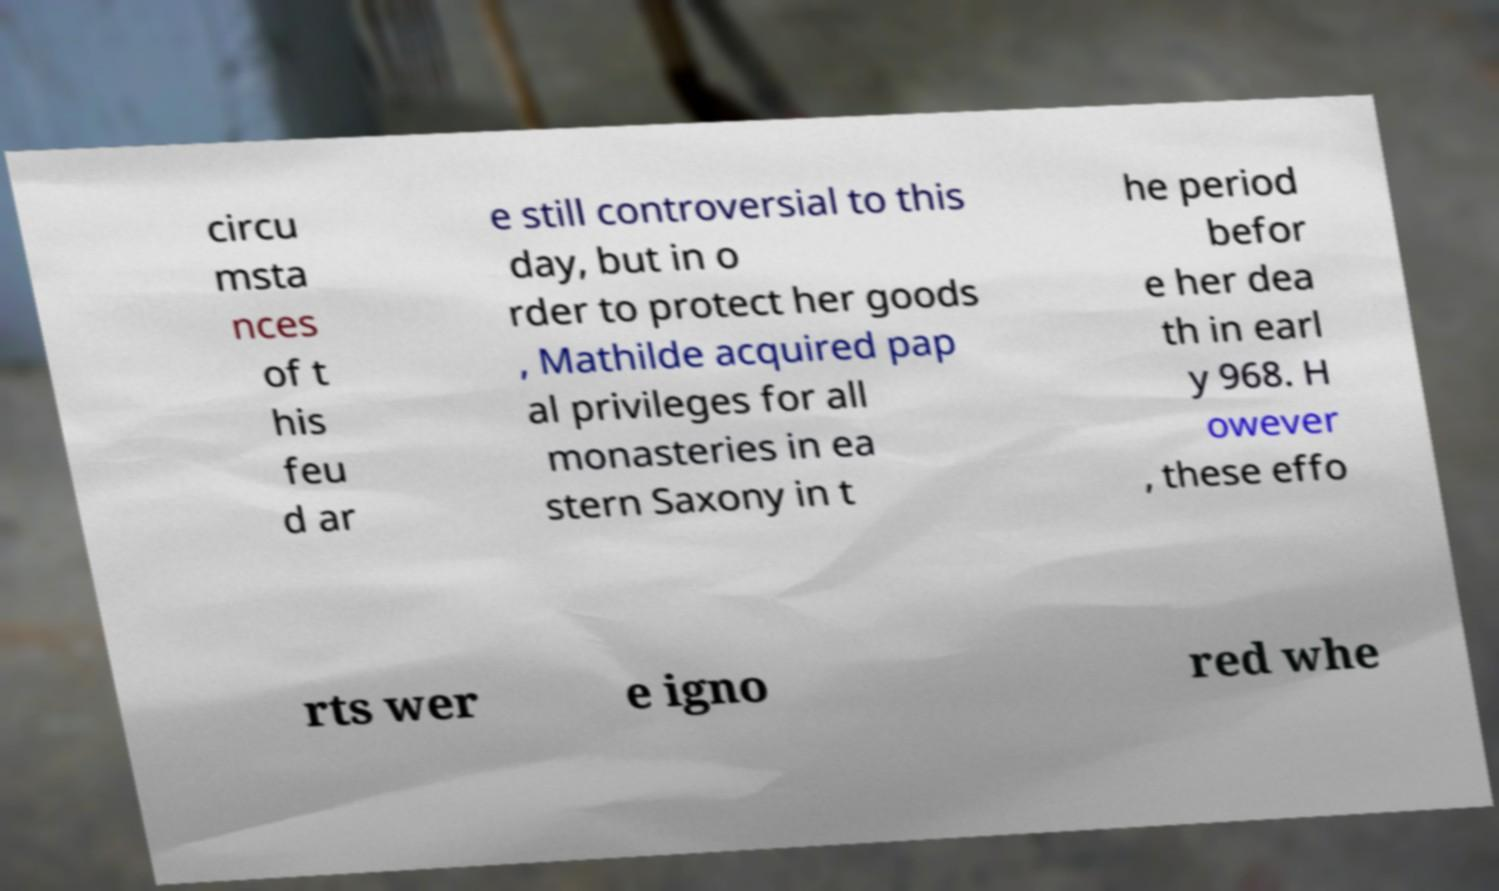For documentation purposes, I need the text within this image transcribed. Could you provide that? circu msta nces of t his feu d ar e still controversial to this day, but in o rder to protect her goods , Mathilde acquired pap al privileges for all monasteries in ea stern Saxony in t he period befor e her dea th in earl y 968. H owever , these effo rts wer e igno red whe 